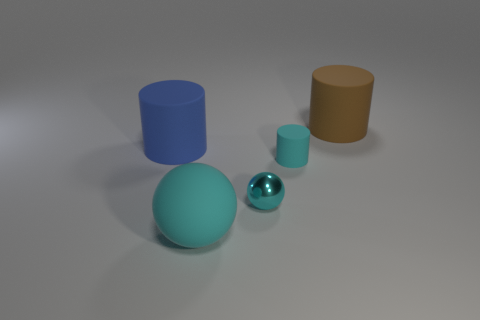Add 4 rubber things. How many objects exist? 9 Subtract all balls. How many objects are left? 3 Add 2 cyan balls. How many cyan balls are left? 4 Add 3 brown metallic spheres. How many brown metallic spheres exist? 3 Subtract 1 cyan spheres. How many objects are left? 4 Subtract all brown matte blocks. Subtract all metal spheres. How many objects are left? 4 